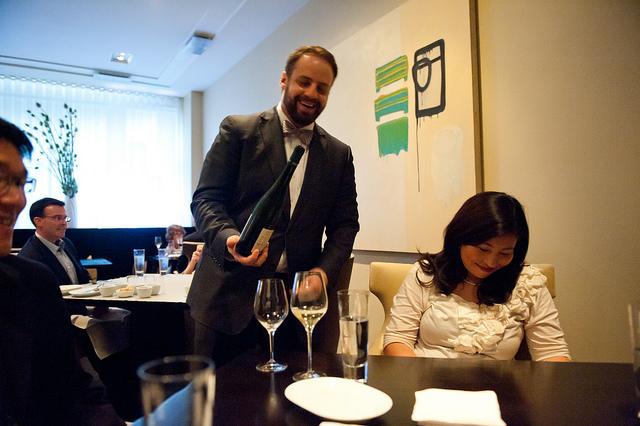What is the woman about to drink?
Keep it brief. Wine. Is the woman happy?
Be succinct. Yes. Is the woman shy?
Short answer required. Yes. 